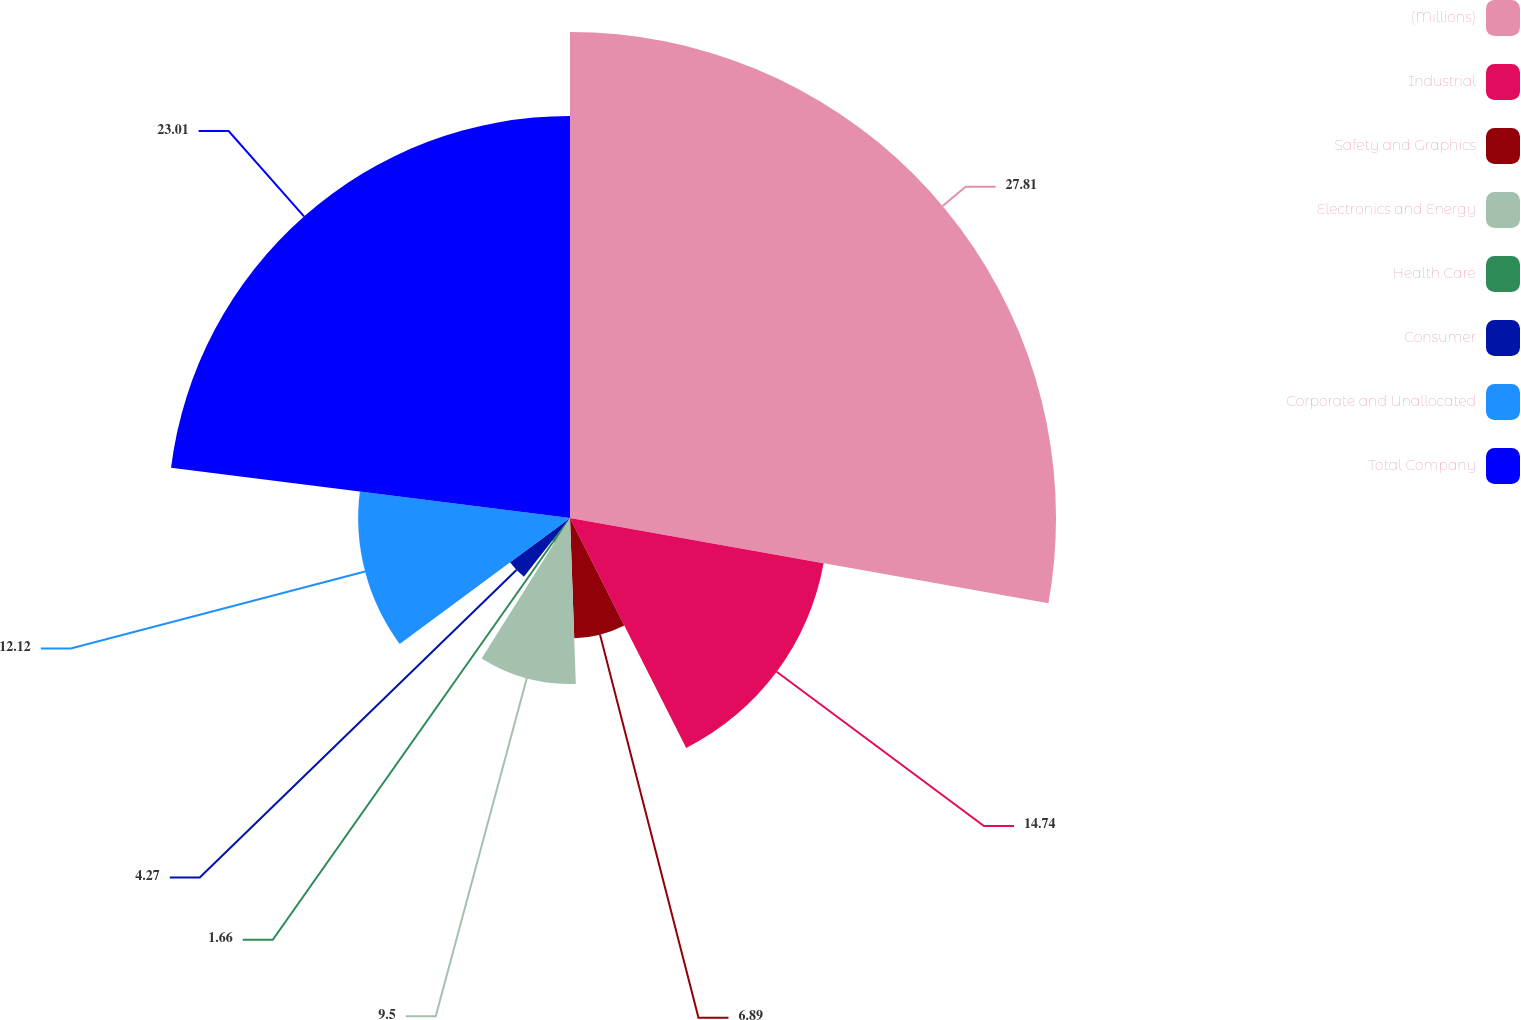Convert chart. <chart><loc_0><loc_0><loc_500><loc_500><pie_chart><fcel>(Millions)<fcel>Industrial<fcel>Safety and Graphics<fcel>Electronics and Energy<fcel>Health Care<fcel>Consumer<fcel>Corporate and Unallocated<fcel>Total Company<nl><fcel>27.81%<fcel>14.74%<fcel>6.89%<fcel>9.5%<fcel>1.66%<fcel>4.27%<fcel>12.12%<fcel>23.01%<nl></chart> 